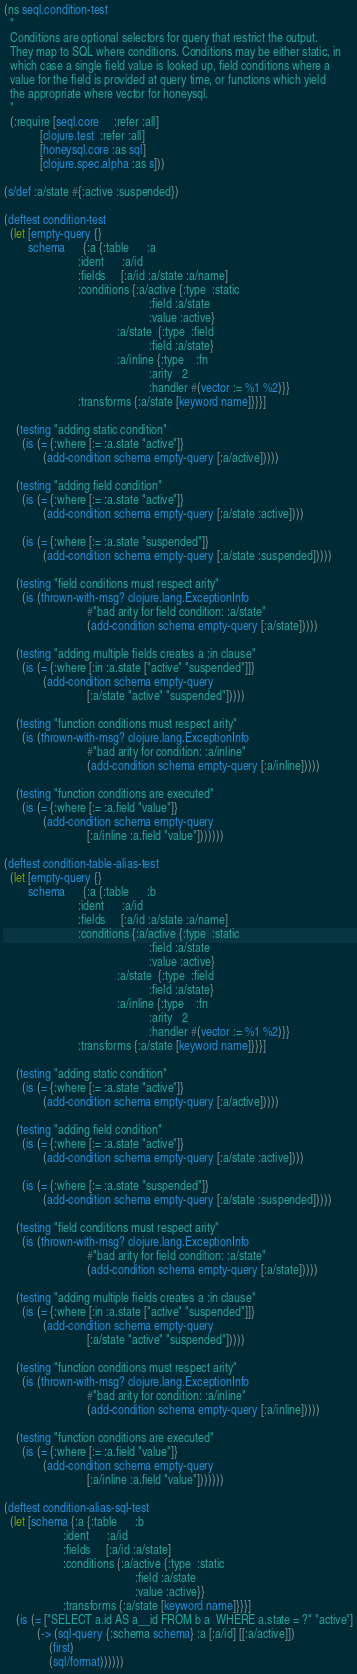Convert code to text. <code><loc_0><loc_0><loc_500><loc_500><_Clojure_>(ns seql.condition-test
  "
  Conditions are optional selectors for query that restrict the output.
  They map to SQL where conditions. Conditions may be either static, in
  which case a single field value is looked up, field conditions where a
  value for the field is provided at query time, or functions which yield
  the appropriate where vector for honeysql.
  "
  (:require [seql.core     :refer :all]
            [clojure.test  :refer :all]
            [honeysql.core :as sql]
            [clojure.spec.alpha :as s]))

(s/def :a/state #{:active :suspended})

(deftest condition-test
  (let [empty-query {}
        schema      {:a {:table      :a
                         :ident      :a/id
                         :fields     [:a/id :a/state :a/name]
                         :conditions {:a/active {:type  :static
                                                 :field :a/state
                                                 :value :active}
                                      :a/state  {:type  :field
                                                 :field :a/state}
                                      :a/inline {:type    :fn
                                                 :arity   2
                                                 :handler #(vector := %1 %2)}}
                         :transforms {:a/state [keyword name]}}}]

    (testing "adding static condition"
      (is (= {:where [:= :a.state "active"]}
             (add-condition schema empty-query [:a/active]))))

    (testing "adding field condition"
      (is (= {:where [:= :a.state "active"]}
             (add-condition schema empty-query [:a/state :active])))

      (is (= {:where [:= :a.state "suspended"]}
             (add-condition schema empty-query [:a/state :suspended]))))

    (testing "field conditions must respect arity"
      (is (thrown-with-msg? clojure.lang.ExceptionInfo
                            #"bad arity for field condition: :a/state"
                            (add-condition schema empty-query [:a/state]))))

    (testing "adding multiple fields creates a :in clause"
      (is (= {:where [:in :a.state ["active" "suspended"]]}
             (add-condition schema empty-query
                            [:a/state "active" "suspended"]))))

    (testing "function conditions must respect arity"
      (is (thrown-with-msg? clojure.lang.ExceptionInfo
                            #"bad arity for condition: :a/inline"
                            (add-condition schema empty-query [:a/inline]))))

    (testing "function conditions are executed"
      (is (= {:where [:= :a.field "value"]}
             (add-condition schema empty-query
                            [:a/inline :a.field "value"]))))))

(deftest condition-table-alias-test
  (let [empty-query {}
        schema      {:a {:table      :b
                         :ident      :a/id
                         :fields     [:a/id :a/state :a/name]
                         :conditions {:a/active {:type  :static
                                                 :field :a/state
                                                 :value :active}
                                      :a/state  {:type  :field
                                                 :field :a/state}
                                      :a/inline {:type    :fn
                                                 :arity   2
                                                 :handler #(vector := %1 %2)}}
                         :transforms {:a/state [keyword name]}}}]

    (testing "adding static condition"
      (is (= {:where [:= :a.state "active"]}
             (add-condition schema empty-query [:a/active]))))

    (testing "adding field condition"
      (is (= {:where [:= :a.state "active"]}
             (add-condition schema empty-query [:a/state :active])))

      (is (= {:where [:= :a.state "suspended"]}
             (add-condition schema empty-query [:a/state :suspended]))))

    (testing "field conditions must respect arity"
      (is (thrown-with-msg? clojure.lang.ExceptionInfo
                            #"bad arity for field condition: :a/state"
                            (add-condition schema empty-query [:a/state]))))

    (testing "adding multiple fields creates a :in clause"
      (is (= {:where [:in :a.state ["active" "suspended"]]}
             (add-condition schema empty-query
                            [:a/state "active" "suspended"]))))

    (testing "function conditions must respect arity"
      (is (thrown-with-msg? clojure.lang.ExceptionInfo
                            #"bad arity for condition: :a/inline"
                            (add-condition schema empty-query [:a/inline]))))

    (testing "function conditions are executed"
      (is (= {:where [:= :a.field "value"]}
             (add-condition schema empty-query
                            [:a/inline :a.field "value"]))))))

(deftest condition-alias-sql-test
  (let [schema {:a {:table      :b
                    :ident      :a/id
                    :fields     [:a/id :a/state]
                    :conditions {:a/active {:type  :static
                                            :field :a/state
                                            :value :active}}
                    :transforms {:a/state [keyword name]}}}]
    (is (= ["SELECT a.id AS a__id FROM b a  WHERE a.state = ?" "active"]
           (-> (sql-query {:schema schema} :a [:a/id] [[:a/active]])
               (first)
               (sql/format))))))
</code> 